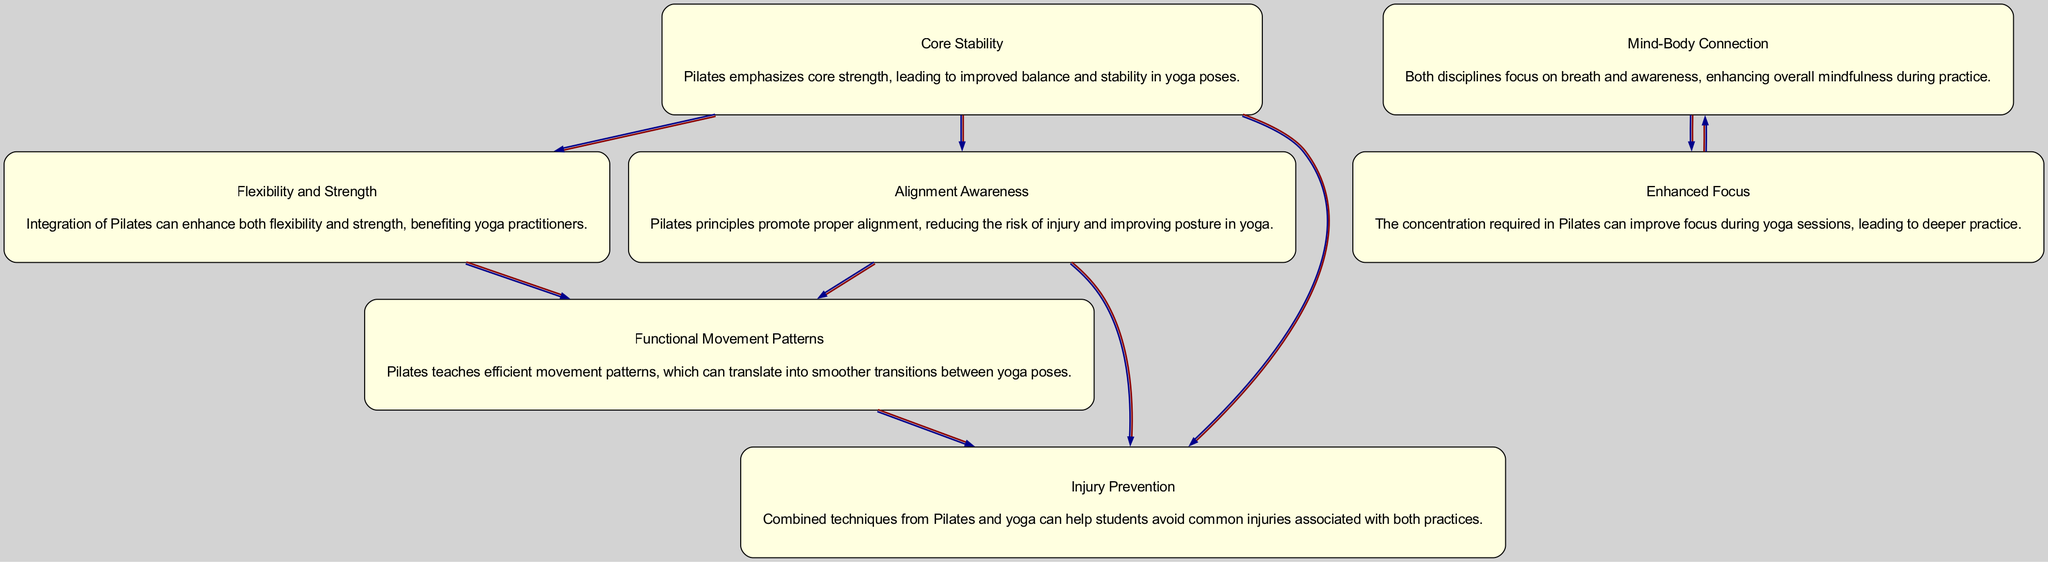What is the main focus of Pilates principles in yoga? The main focus of Pilates principles in yoga is on core stability, which is represented by node 1 in the diagram.
Answer: Core Stability How many nodes are present in the diagram? The diagram contains 7 nodes, each representing a different benefit of integrating Pilates into yoga.
Answer: 7 Which node emphasizes the relationship between concentration in Pilates and yoga practice? Node 6 emphasizes enhanced focus, showing how concentration in Pilates can improve focus during yoga sessions.
Answer: Enhanced Focus Which two nodes are directly connected to "Core Stability"? The nodes directly connected to "Core Stability" are "Alignment Awareness" and "Flexibility and Strength," indicating their relationship to core strength.
Answer: Alignment Awareness and Flexibility and Strength What is the relationship between "Injury Prevention" and "Alignment Awareness"? "Injury Prevention" is influenced by "Alignment Awareness," as proper alignment reduces the risk of injuries, making them directly connected in the diagram.
Answer: Alignment Awareness Which principles can lead to smoother transitions in yoga poses? The principles of Functional Movement Patterns, as indicated by node 5, teach efficient movement patterns that facilitate transitions in yoga.
Answer: Functional Movement Patterns How does the "Mind-Body Connection" relate to the overall experience of yoga practice? The "Mind-Body Connection" (node 2) enhances overall mindfulness during practice, which is vital for students’ experiences in yoga.
Answer: Mind-Body Connection What connects "Flexibility and Strength" to "Injury Prevention"? "Flexibility and Strength" (node 4) directly leads to "Injury Prevention" (node 7), showing that increased flexibility and strength help in injury avoidance.
Answer: Flexibility and Strength How many edges are present in the graph? The graph contains 8 edges, which show the connections between the various nodes.
Answer: 8 